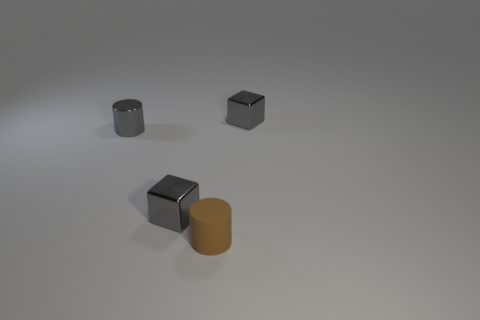What number of tiny rubber cylinders have the same color as the tiny rubber thing?
Make the answer very short. 0. There is a gray cylinder; are there any gray shiny things behind it?
Your answer should be compact. Yes. Is the shape of the brown matte object the same as the small metal thing in front of the shiny cylinder?
Provide a succinct answer. No. What number of things are either gray objects that are in front of the gray cylinder or large green metallic things?
Give a very brief answer. 1. Is there anything else that is the same material as the brown object?
Keep it short and to the point. No. How many tiny shiny cubes are both to the left of the brown object and behind the tiny gray metallic cylinder?
Offer a terse response. 0. How many objects are either gray things left of the brown object or gray blocks that are to the left of the tiny brown rubber cylinder?
Provide a succinct answer. 2. There is a cylinder in front of the gray metal cylinder; is it the same color as the small metallic cylinder?
Provide a succinct answer. No. How many other objects are there of the same size as the matte object?
Make the answer very short. 3. Do the gray cylinder and the tiny brown cylinder have the same material?
Provide a short and direct response. No. 